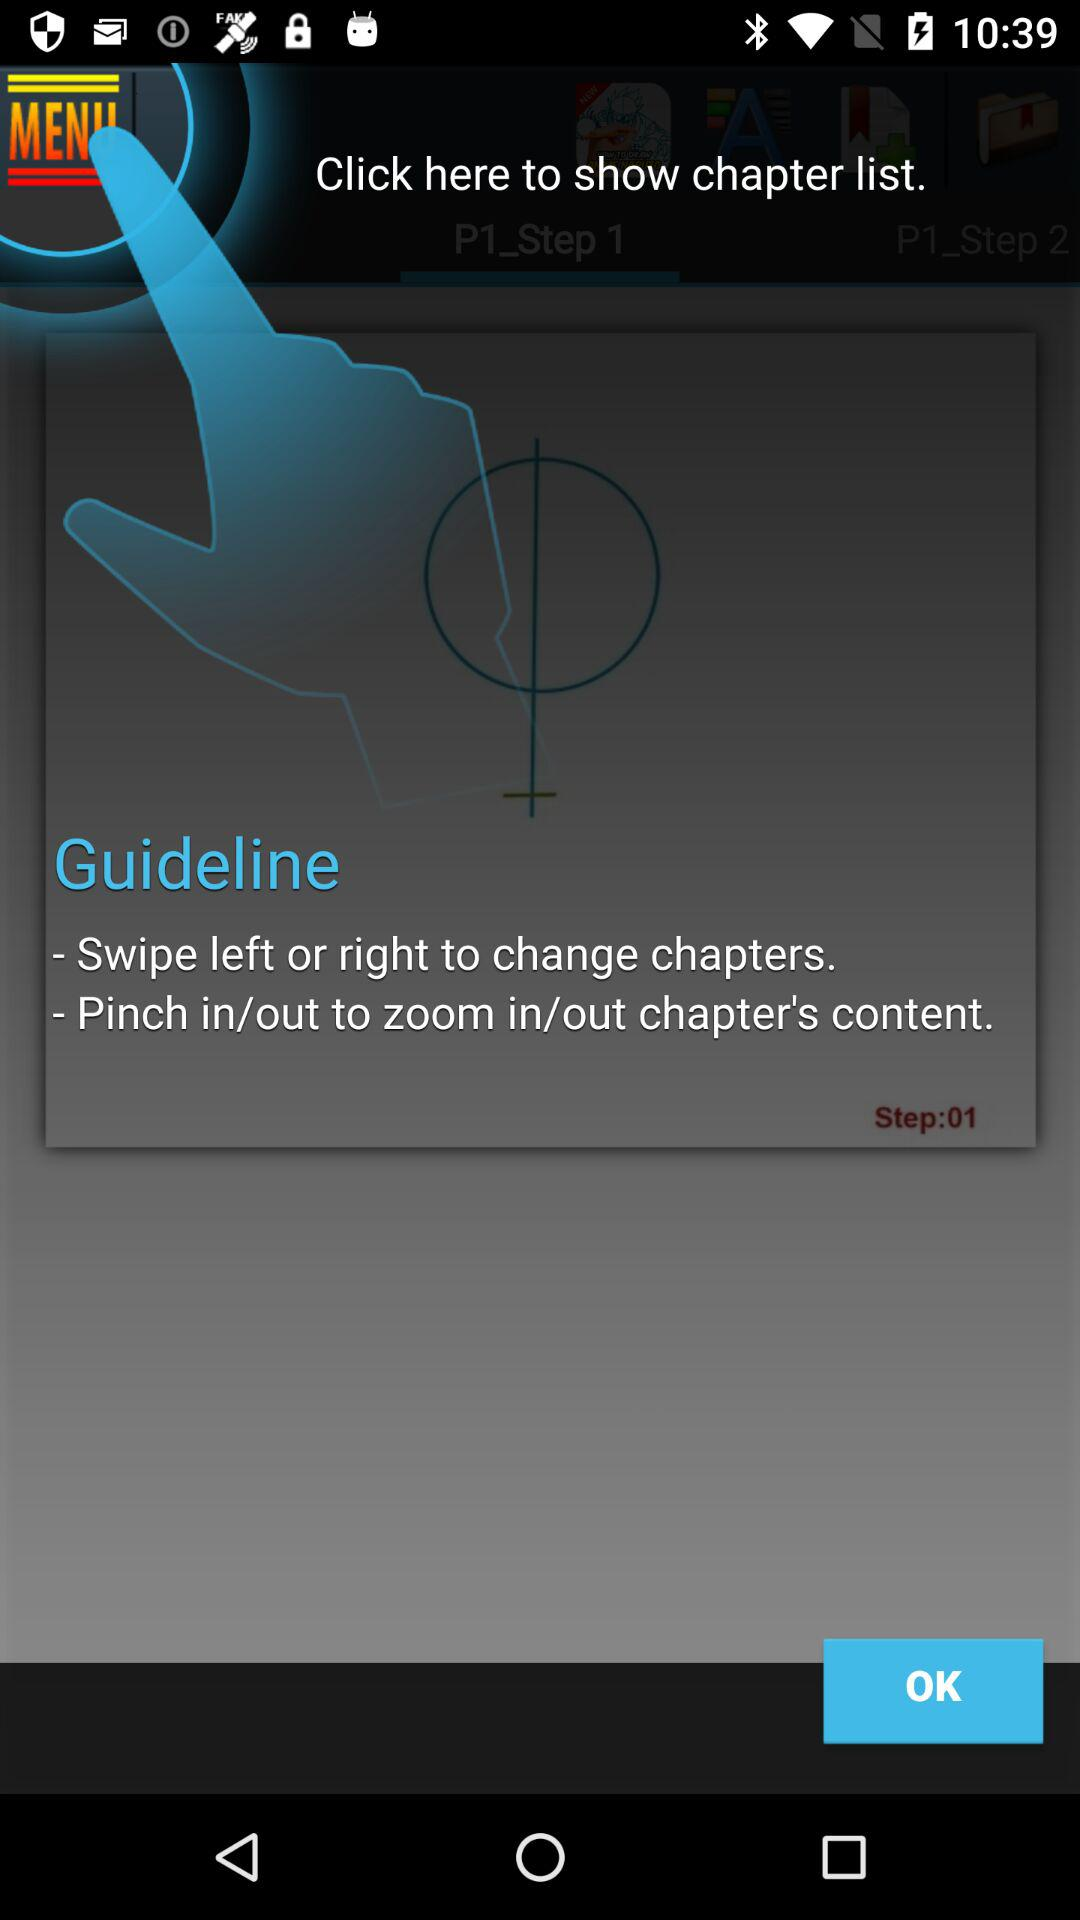Which step is currently shown? The currently shown step is 1. 